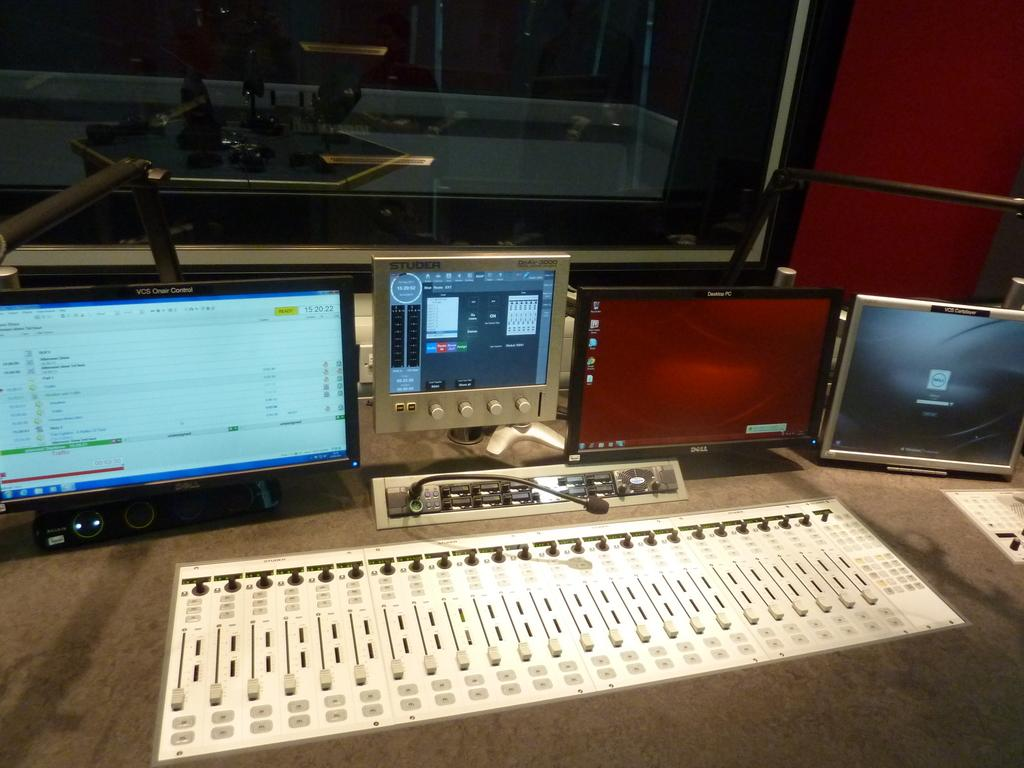<image>
Write a terse but informative summary of the picture. a recording studio console with a VCS Control monitor 